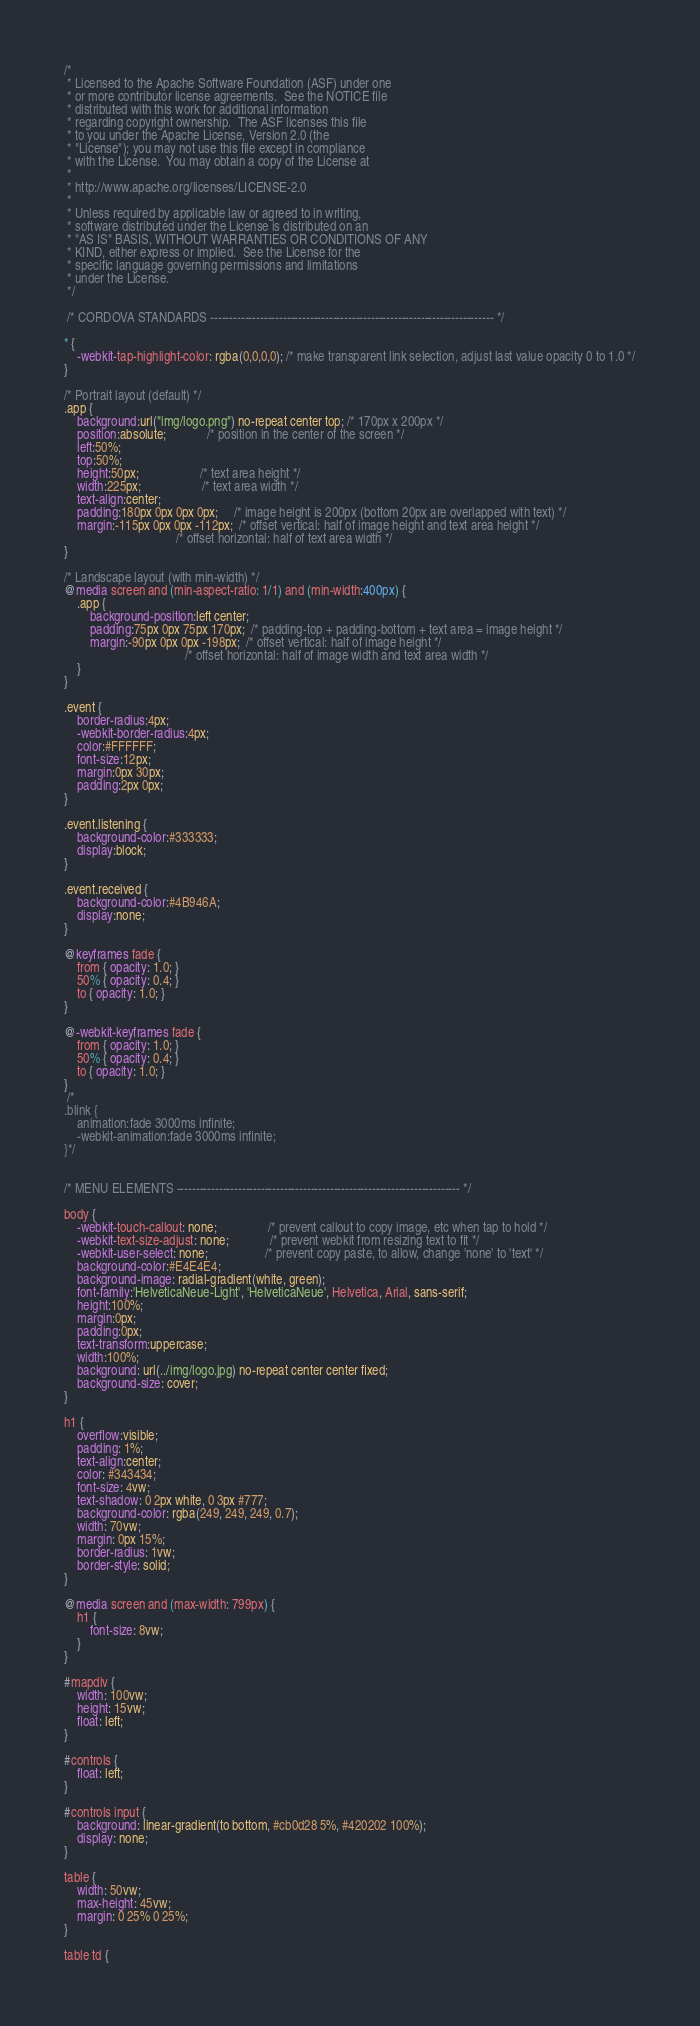Convert code to text. <code><loc_0><loc_0><loc_500><loc_500><_CSS_>/*
 * Licensed to the Apache Software Foundation (ASF) under one
 * or more contributor license agreements.  See the NOTICE file
 * distributed with this work for additional information
 * regarding copyright ownership.  The ASF licenses this file
 * to you under the Apache License, Version 2.0 (the
 * "License"); you may not use this file except in compliance
 * with the License.  You may obtain a copy of the License at
 *
 * http://www.apache.org/licenses/LICENSE-2.0
 *
 * Unless required by applicable law or agreed to in writing,
 * software distributed under the License is distributed on an
 * "AS IS" BASIS, WITHOUT WARRANTIES OR CONDITIONS OF ANY
 * KIND, either express or implied.  See the License for the
 * specific language governing permissions and limitations
 * under the License.
 */
 
 /* CORDOVA STANDARDS -------------------------------------------------------------------------- */
 
* {
    -webkit-tap-highlight-color: rgba(0,0,0,0); /* make transparent link selection, adjust last value opacity 0 to 1.0 */
}

/* Portrait layout (default) */
.app {
    background:url("img/logo.png") no-repeat center top; /* 170px x 200px */
    position:absolute;             /* position in the center of the screen */
    left:50%;
    top:50%;
    height:50px;                   /* text area height */
    width:225px;                   /* text area width */
    text-align:center;
    padding:180px 0px 0px 0px;     /* image height is 200px (bottom 20px are overlapped with text) */
    margin:-115px 0px 0px -112px;  /* offset vertical: half of image height and text area height */
                                   /* offset horizontal: half of text area width */
}

/* Landscape layout (with min-width) */
@media screen and (min-aspect-ratio: 1/1) and (min-width:400px) {
    .app {
        background-position:left center;
        padding:75px 0px 75px 170px;  /* padding-top + padding-bottom + text area = image height */
        margin:-90px 0px 0px -198px;  /* offset vertical: half of image height */
                                      /* offset horizontal: half of image width and text area width */
    }
}

.event {
    border-radius:4px;
    -webkit-border-radius:4px;
    color:#FFFFFF;
    font-size:12px;
    margin:0px 30px;
    padding:2px 0px;
}

.event.listening {
    background-color:#333333;
    display:block;
}

.event.received {
    background-color:#4B946A;
    display:none;
}

@keyframes fade {
    from { opacity: 1.0; }
    50% { opacity: 0.4; }
    to { opacity: 1.0; }
}
 
@-webkit-keyframes fade {
    from { opacity: 1.0; }
    50% { opacity: 0.4; }
    to { opacity: 1.0; }
}
 /*
.blink {
    animation:fade 3000ms infinite;
    -webkit-animation:fade 3000ms infinite;
}*/


/* MENU ELEMENTS -------------------------------------------------------------------------- */

body {
    -webkit-touch-callout: none;                /* prevent callout to copy image, etc when tap to hold */
    -webkit-text-size-adjust: none;             /* prevent webkit from resizing text to fit */
    -webkit-user-select: none;                  /* prevent copy paste, to allow, change 'none' to 'text' */
    background-color:#E4E4E4;
	background-image: radial-gradient(white, green);
    font-family:'HelveticaNeue-Light', 'HelveticaNeue', Helvetica, Arial, sans-serif;
    height:100%;
    margin:0px;
    padding:0px;
    text-transform:uppercase;
    width:100%;
	background: url(../img/logo.jpg) no-repeat center center fixed;
	background-size: cover;
}

h1 {
    overflow:visible;
    padding: 1%;
    text-align:center;
	color: #343434;
	font-size: 4vw;
	text-shadow: 0 2px white, 0 3px #777;
	background-color: rgba(249, 249, 249, 0.7);
	width: 70vw;
	margin: 0px 15%;
	border-radius: 1vw;
	border-style: solid;
}

@media screen and (max-width: 799px) {
	h1 {
		font-size: 8vw;
	}
}

#mapdiv {
	width: 100vw;
	height: 15vw;
	float: left;
}
		
#controls {
	float: left;
}

#controls input {
	background: linear-gradient(to bottom, #cb0d28 5%, #420202 100%);
	display: none;
}
		
table {
	width: 50vw;
	max-height: 45vw;
	margin: 0 25% 0 25%;
}
		
table td {</code> 